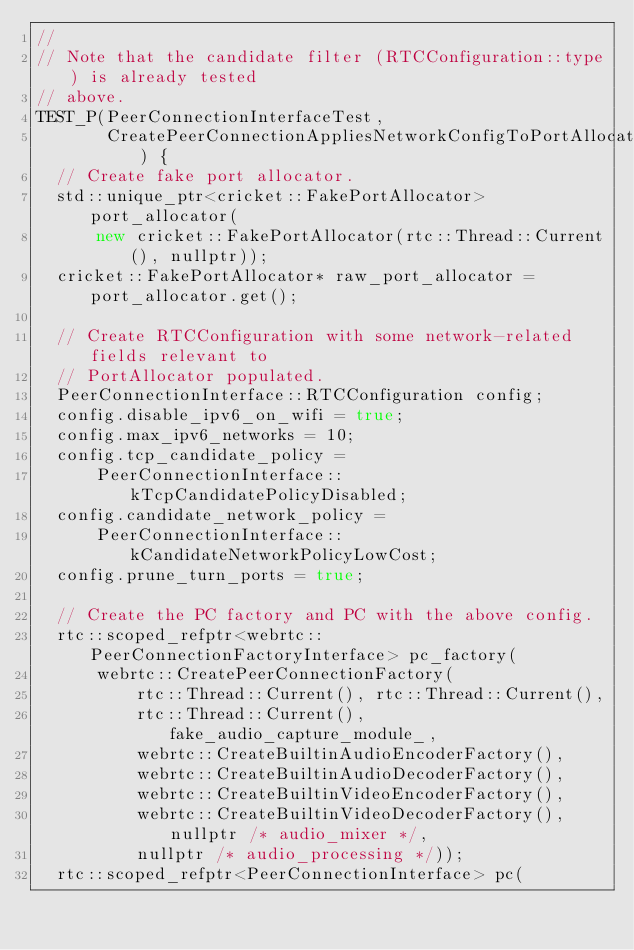<code> <loc_0><loc_0><loc_500><loc_500><_C++_>//
// Note that the candidate filter (RTCConfiguration::type) is already tested
// above.
TEST_P(PeerConnectionInterfaceTest,
       CreatePeerConnectionAppliesNetworkConfigToPortAllocator) {
  // Create fake port allocator.
  std::unique_ptr<cricket::FakePortAllocator> port_allocator(
      new cricket::FakePortAllocator(rtc::Thread::Current(), nullptr));
  cricket::FakePortAllocator* raw_port_allocator = port_allocator.get();

  // Create RTCConfiguration with some network-related fields relevant to
  // PortAllocator populated.
  PeerConnectionInterface::RTCConfiguration config;
  config.disable_ipv6_on_wifi = true;
  config.max_ipv6_networks = 10;
  config.tcp_candidate_policy =
      PeerConnectionInterface::kTcpCandidatePolicyDisabled;
  config.candidate_network_policy =
      PeerConnectionInterface::kCandidateNetworkPolicyLowCost;
  config.prune_turn_ports = true;

  // Create the PC factory and PC with the above config.
  rtc::scoped_refptr<webrtc::PeerConnectionFactoryInterface> pc_factory(
      webrtc::CreatePeerConnectionFactory(
          rtc::Thread::Current(), rtc::Thread::Current(),
          rtc::Thread::Current(), fake_audio_capture_module_,
          webrtc::CreateBuiltinAudioEncoderFactory(),
          webrtc::CreateBuiltinAudioDecoderFactory(),
          webrtc::CreateBuiltinVideoEncoderFactory(),
          webrtc::CreateBuiltinVideoDecoderFactory(), nullptr /* audio_mixer */,
          nullptr /* audio_processing */));
  rtc::scoped_refptr<PeerConnectionInterface> pc(</code> 